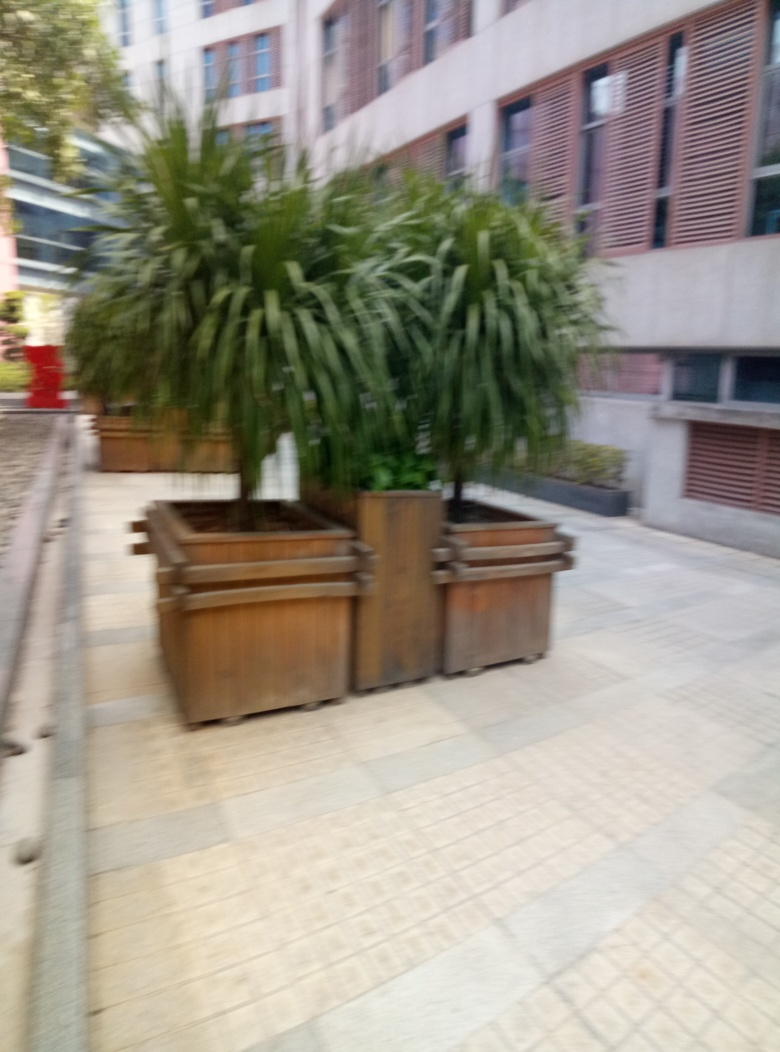Can you guess what time of day this photo was taken? Given the level of natural light and the absence of prominent shadows, it appears to be taken during an overcast day or possibly around dusk. However, the exact time cannot be determined with certainty due to the blurring of the image. 